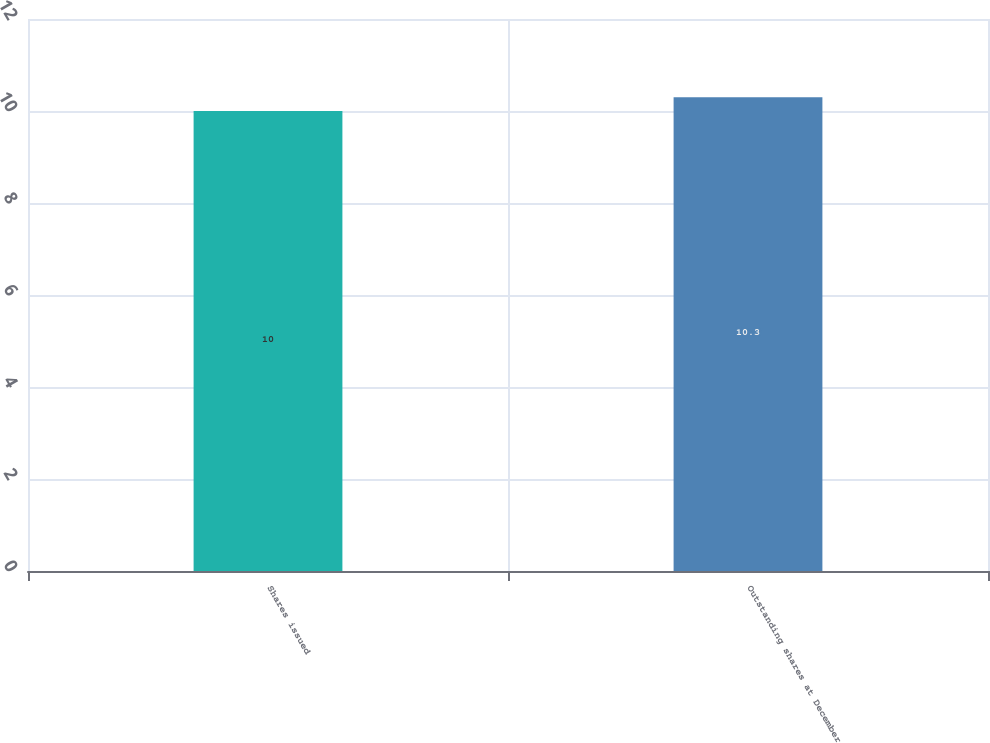Convert chart. <chart><loc_0><loc_0><loc_500><loc_500><bar_chart><fcel>Shares issued<fcel>Outstanding shares at December<nl><fcel>10<fcel>10.3<nl></chart> 